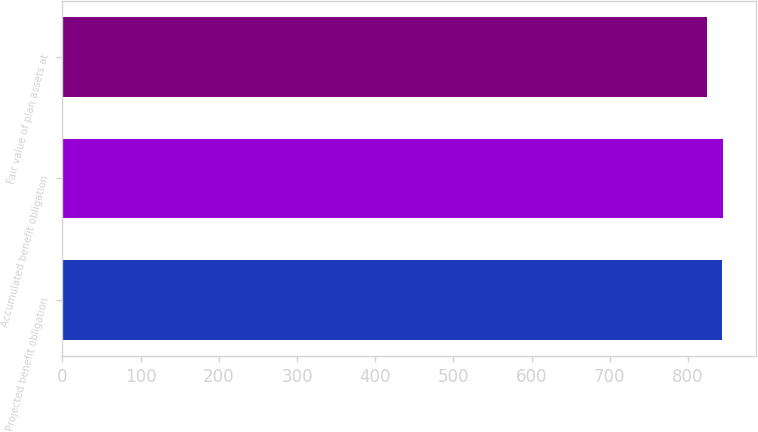<chart> <loc_0><loc_0><loc_500><loc_500><bar_chart><fcel>Projected benefit obligation<fcel>Accumulated benefit obligation<fcel>Fair value of plan assets at<nl><fcel>843<fcel>844.8<fcel>825<nl></chart> 